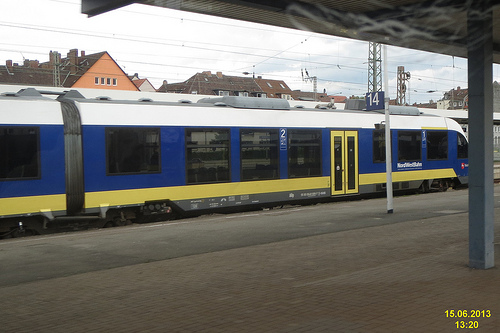Which place is it? This is a train station, identifiable by the train present on the tracks and platform indicators such as the number 14. 